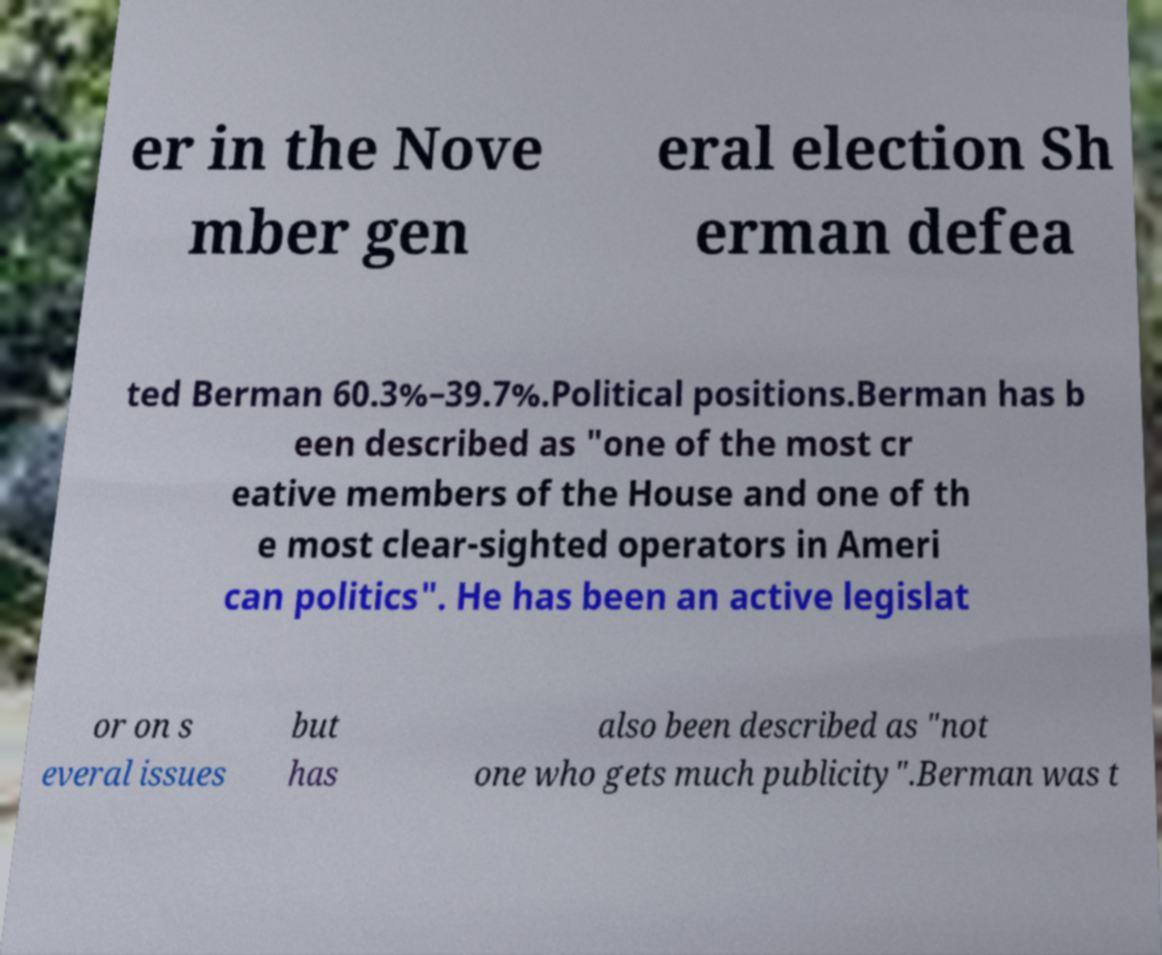Can you accurately transcribe the text from the provided image for me? er in the Nove mber gen eral election Sh erman defea ted Berman 60.3%–39.7%.Political positions.Berman has b een described as "one of the most cr eative members of the House and one of th e most clear-sighted operators in Ameri can politics". He has been an active legislat or on s everal issues but has also been described as "not one who gets much publicity".Berman was t 